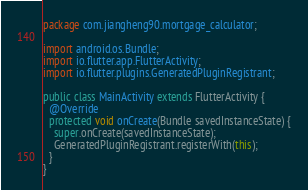Convert code to text. <code><loc_0><loc_0><loc_500><loc_500><_Java_>package com.jiangheng90.mortgage_calculator;

import android.os.Bundle;
import io.flutter.app.FlutterActivity;
import io.flutter.plugins.GeneratedPluginRegistrant;

public class MainActivity extends FlutterActivity {
  @Override
  protected void onCreate(Bundle savedInstanceState) {
    super.onCreate(savedInstanceState);
    GeneratedPluginRegistrant.registerWith(this);
  }
}
</code> 